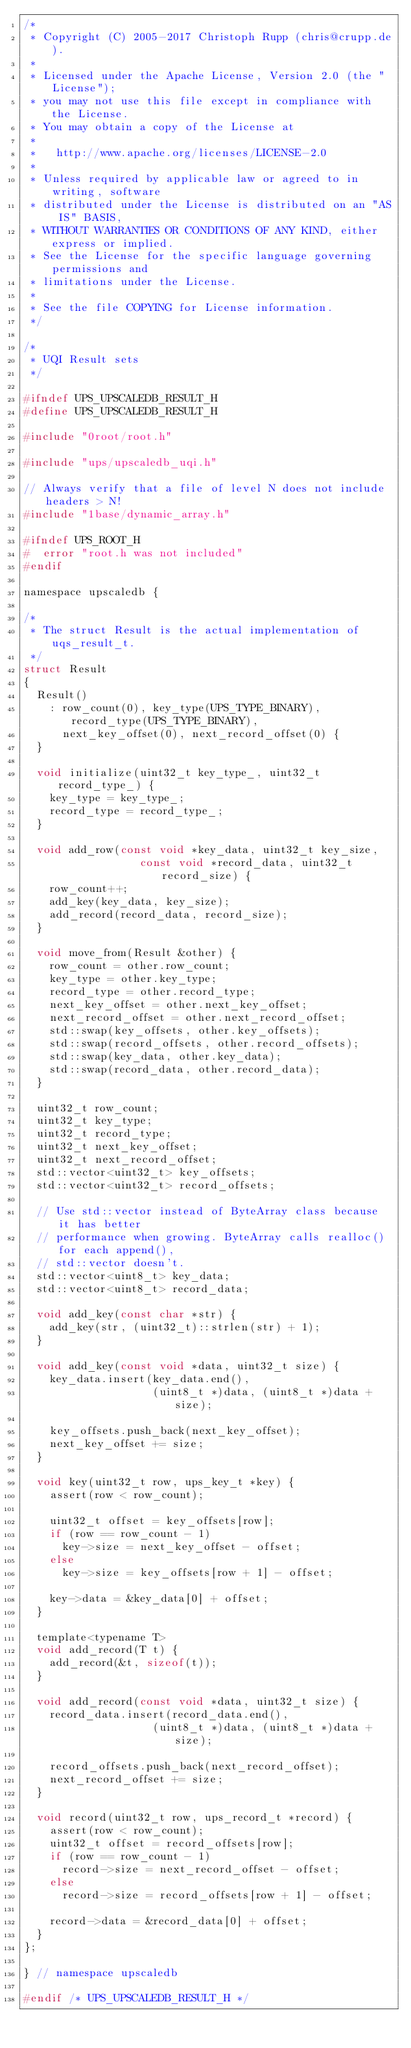<code> <loc_0><loc_0><loc_500><loc_500><_C_>/*
 * Copyright (C) 2005-2017 Christoph Rupp (chris@crupp.de).
 *
 * Licensed under the Apache License, Version 2.0 (the "License");
 * you may not use this file except in compliance with the License.
 * You may obtain a copy of the License at
 *
 *   http://www.apache.org/licenses/LICENSE-2.0
 *
 * Unless required by applicable law or agreed to in writing, software
 * distributed under the License is distributed on an "AS IS" BASIS,
 * WITHOUT WARRANTIES OR CONDITIONS OF ANY KIND, either express or implied.
 * See the License for the specific language governing permissions and
 * limitations under the License.
 *
 * See the file COPYING for License information.
 */

/*
 * UQI Result sets
 */

#ifndef UPS_UPSCALEDB_RESULT_H
#define UPS_UPSCALEDB_RESULT_H

#include "0root/root.h"

#include "ups/upscaledb_uqi.h"

// Always verify that a file of level N does not include headers > N!
#include "1base/dynamic_array.h"

#ifndef UPS_ROOT_H
#  error "root.h was not included"
#endif

namespace upscaledb {

/*
 * The struct Result is the actual implementation of uqs_result_t.
 */
struct Result
{
  Result()
    : row_count(0), key_type(UPS_TYPE_BINARY), record_type(UPS_TYPE_BINARY),
      next_key_offset(0), next_record_offset(0) {
  }

  void initialize(uint32_t key_type_, uint32_t record_type_) {
    key_type = key_type_;
    record_type = record_type_;
  }

  void add_row(const void *key_data, uint32_t key_size,
                  const void *record_data, uint32_t record_size) {
    row_count++;
    add_key(key_data, key_size);
    add_record(record_data, record_size);
  }

  void move_from(Result &other) {
    row_count = other.row_count;
    key_type = other.key_type;
    record_type = other.record_type;
    next_key_offset = other.next_key_offset;
    next_record_offset = other.next_record_offset;
    std::swap(key_offsets, other.key_offsets);
    std::swap(record_offsets, other.record_offsets);
    std::swap(key_data, other.key_data);
    std::swap(record_data, other.record_data);
  }

  uint32_t row_count;
  uint32_t key_type;
  uint32_t record_type;
  uint32_t next_key_offset;
  uint32_t next_record_offset;
  std::vector<uint32_t> key_offsets;
  std::vector<uint32_t> record_offsets;

  // Use std::vector instead of ByteArray class because it has better
  // performance when growing. ByteArray calls realloc() for each append(),
  // std::vector doesn't.
  std::vector<uint8_t> key_data;
  std::vector<uint8_t> record_data;

  void add_key(const char *str) {
    add_key(str, (uint32_t)::strlen(str) + 1);
  }

  void add_key(const void *data, uint32_t size) {
    key_data.insert(key_data.end(),
                    (uint8_t *)data, (uint8_t *)data + size);

    key_offsets.push_back(next_key_offset);
    next_key_offset += size;
  }

  void key(uint32_t row, ups_key_t *key) {
    assert(row < row_count);

    uint32_t offset = key_offsets[row];
    if (row == row_count - 1)
      key->size = next_key_offset - offset;
    else
      key->size = key_offsets[row + 1] - offset;

    key->data = &key_data[0] + offset;
  }

  template<typename T>
  void add_record(T t) {
    add_record(&t, sizeof(t));
  }

  void add_record(const void *data, uint32_t size) {
    record_data.insert(record_data.end(),
                    (uint8_t *)data, (uint8_t *)data + size);

    record_offsets.push_back(next_record_offset);
    next_record_offset += size;
  }

  void record(uint32_t row, ups_record_t *record) {
    assert(row < row_count);
    uint32_t offset = record_offsets[row];
    if (row == row_count - 1)
      record->size = next_record_offset - offset;
    else
      record->size = record_offsets[row + 1] - offset;

    record->data = &record_data[0] + offset;
  }
};

} // namespace upscaledb

#endif /* UPS_UPSCALEDB_RESULT_H */
</code> 